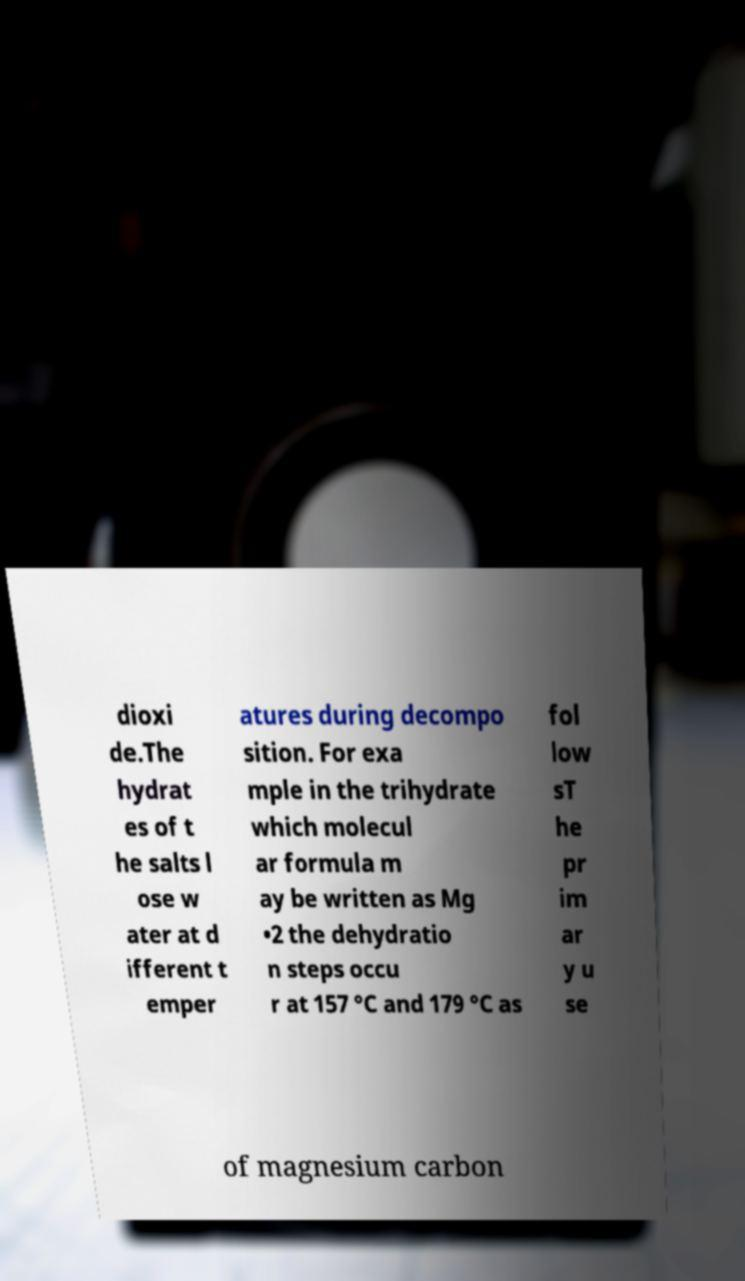I need the written content from this picture converted into text. Can you do that? dioxi de.The hydrat es of t he salts l ose w ater at d ifferent t emper atures during decompo sition. For exa mple in the trihydrate which molecul ar formula m ay be written as Mg •2 the dehydratio n steps occu r at 157 °C and 179 °C as fol low sT he pr im ar y u se of magnesium carbon 